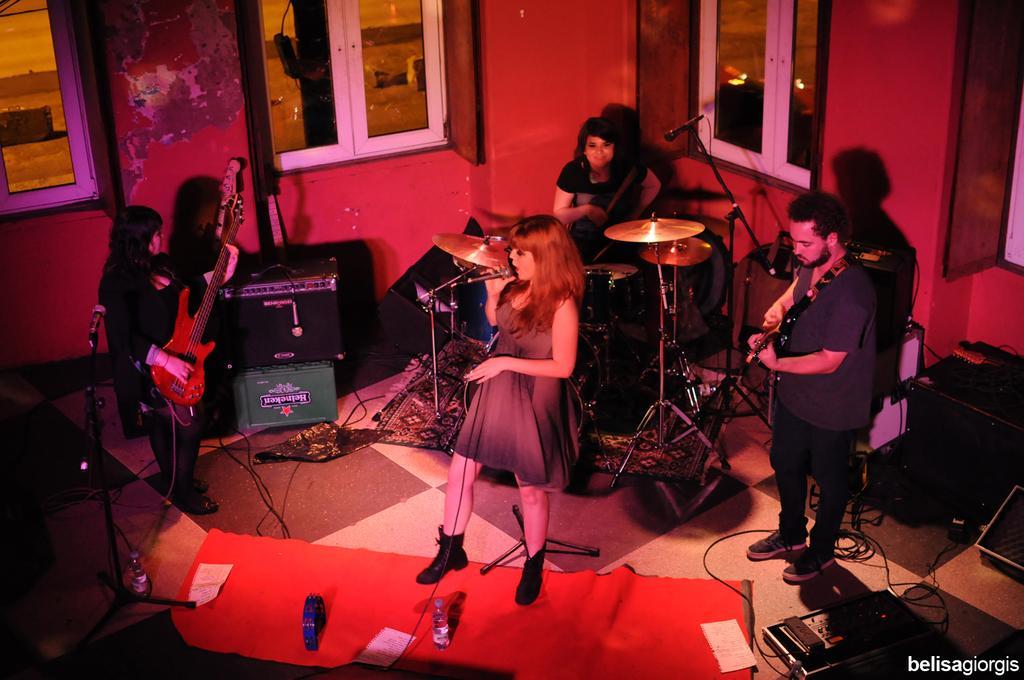How would you summarize this image in a sentence or two? In this picture there are several people playing musical instruments ,among them few are playing drums , guitar and a girl is singing with a mic in her hand. In the background we observe glass windows and the whole area is red in color. 